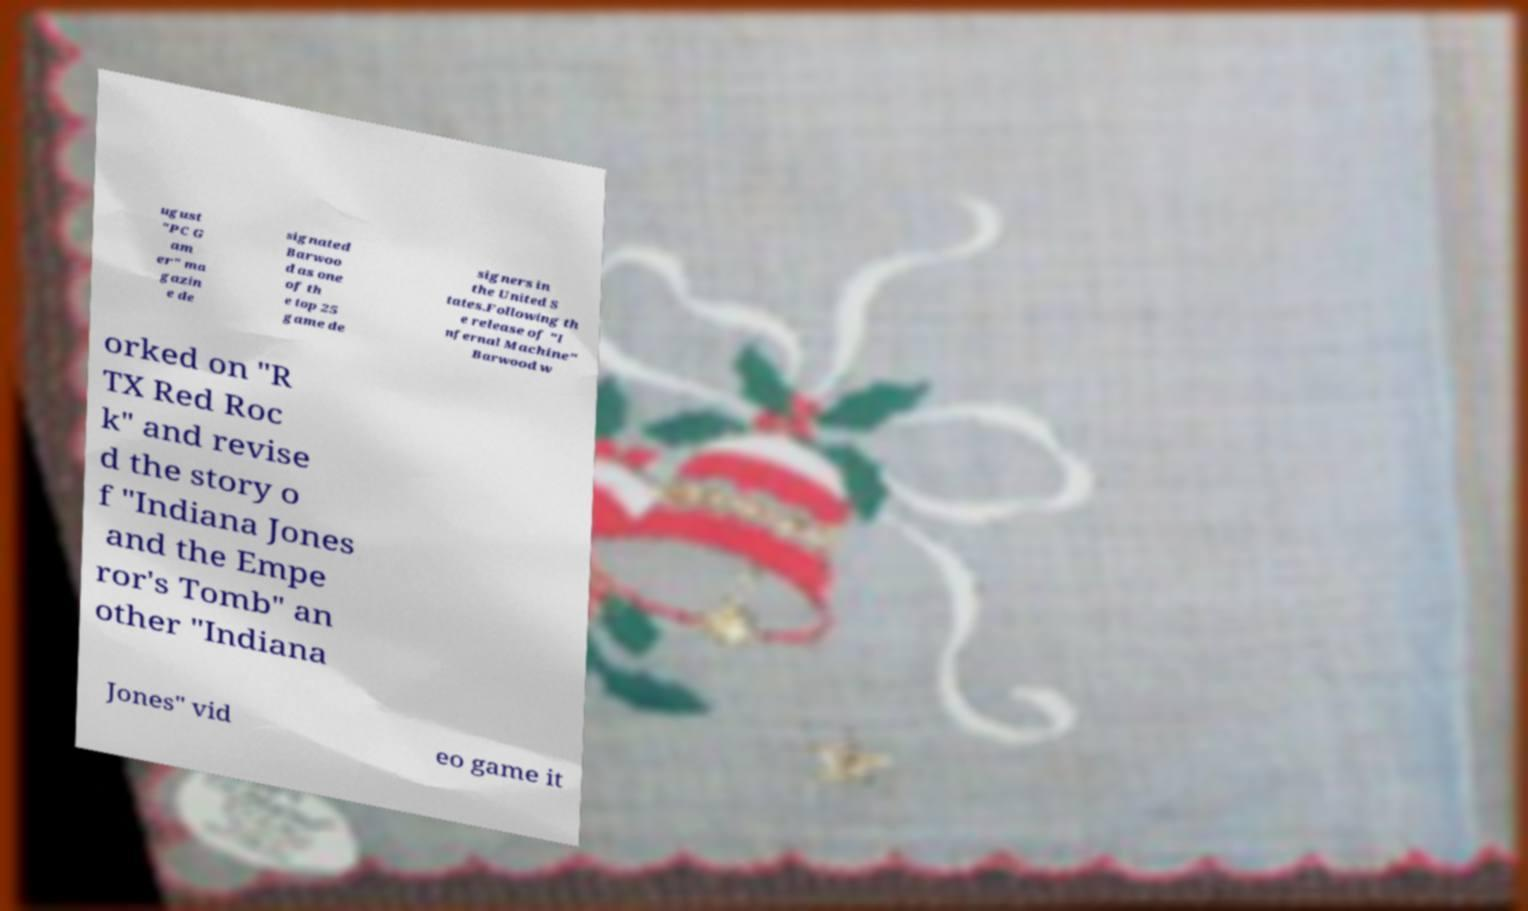What messages or text are displayed in this image? I need them in a readable, typed format. ugust "PC G am er" ma gazin e de signated Barwoo d as one of th e top 25 game de signers in the United S tates.Following th e release of "I nfernal Machine" Barwood w orked on "R TX Red Roc k" and revise d the story o f "Indiana Jones and the Empe ror's Tomb" an other "Indiana Jones" vid eo game it 